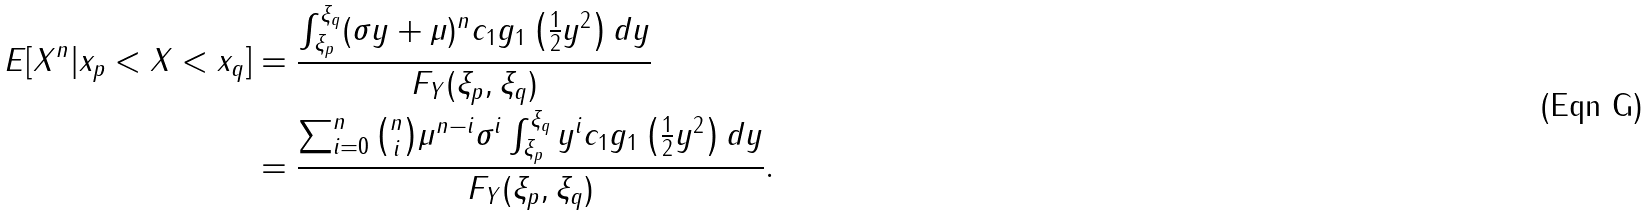Convert formula to latex. <formula><loc_0><loc_0><loc_500><loc_500>E [ X ^ { n } | x _ { p } < X < x _ { q } ] & = \frac { \int _ { \xi _ { p } } ^ { \xi _ { q } } ( \sigma y + \mu ) ^ { n } c _ { 1 } g _ { 1 } \left ( \frac { 1 } { 2 } y ^ { 2 } \right ) d y } { F _ { Y } ( \xi _ { p } , \xi _ { q } ) } \\ & = \frac { \sum _ { i = 0 } ^ { n } \binom { n } { i } \mu ^ { n - i } \sigma ^ { i } \int _ { \xi _ { p } } ^ { \xi _ { q } } y ^ { i } c _ { 1 } g _ { 1 } \left ( \frac { 1 } { 2 } y ^ { 2 } \right ) d y } { F _ { Y } ( \xi _ { p } , \xi _ { q } ) } .</formula> 